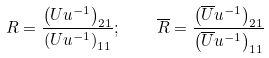<formula> <loc_0><loc_0><loc_500><loc_500>R = \frac { \left ( U u ^ { - 1 } \right ) _ { 2 1 } } { \left ( U u ^ { - 1 } \right ) _ { 1 1 } } ; \quad \overline { R } = \frac { \left ( \overline { U } u ^ { - 1 } \right ) _ { 2 1 } } { \left ( \overline { U } u ^ { - 1 } \right ) _ { 1 1 } }</formula> 